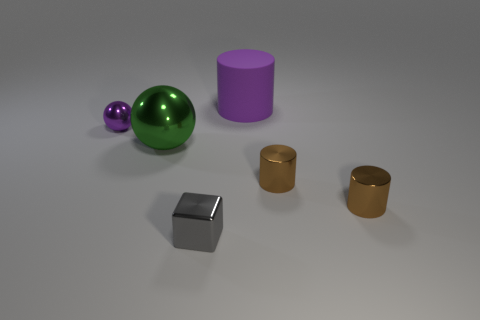Do the large matte object and the small metal ball have the same color?
Your answer should be compact. Yes. What shape is the tiny metallic object that is the same color as the large cylinder?
Your answer should be compact. Sphere. Is there a thing of the same color as the large cylinder?
Your response must be concise. Yes. There is a purple object that is the same size as the gray thing; what is it made of?
Your answer should be compact. Metal. What number of other things are made of the same material as the green sphere?
Provide a succinct answer. 4. There is a object that is both on the right side of the small purple ball and behind the large green shiny object; what color is it?
Keep it short and to the point. Purple. What number of objects are either big purple things on the right side of the small metallic ball or tiny purple metal things?
Your answer should be compact. 2. What number of other things are the same color as the big metallic ball?
Provide a short and direct response. 0. Are there an equal number of blocks that are in front of the tiny gray metallic thing and large purple rubber things?
Ensure brevity in your answer.  No. There is a cylinder behind the metal sphere left of the large sphere; what number of small objects are on the left side of it?
Provide a succinct answer. 2. 